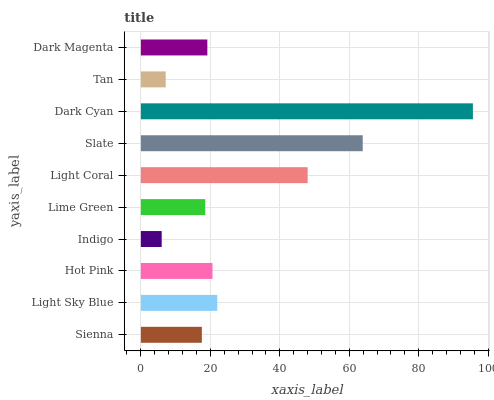Is Indigo the minimum?
Answer yes or no. Yes. Is Dark Cyan the maximum?
Answer yes or no. Yes. Is Light Sky Blue the minimum?
Answer yes or no. No. Is Light Sky Blue the maximum?
Answer yes or no. No. Is Light Sky Blue greater than Sienna?
Answer yes or no. Yes. Is Sienna less than Light Sky Blue?
Answer yes or no. Yes. Is Sienna greater than Light Sky Blue?
Answer yes or no. No. Is Light Sky Blue less than Sienna?
Answer yes or no. No. Is Hot Pink the high median?
Answer yes or no. Yes. Is Dark Magenta the low median?
Answer yes or no. Yes. Is Sienna the high median?
Answer yes or no. No. Is Hot Pink the low median?
Answer yes or no. No. 